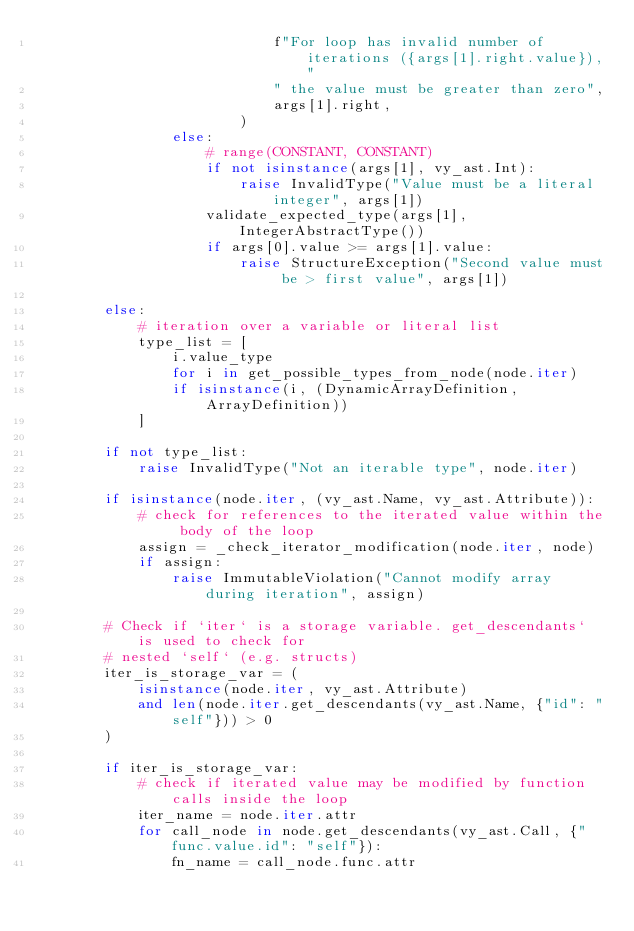<code> <loc_0><loc_0><loc_500><loc_500><_Python_>                            f"For loop has invalid number of iterations ({args[1].right.value}),"
                            " the value must be greater than zero",
                            args[1].right,
                        )
                else:
                    # range(CONSTANT, CONSTANT)
                    if not isinstance(args[1], vy_ast.Int):
                        raise InvalidType("Value must be a literal integer", args[1])
                    validate_expected_type(args[1], IntegerAbstractType())
                    if args[0].value >= args[1].value:
                        raise StructureException("Second value must be > first value", args[1])

        else:
            # iteration over a variable or literal list
            type_list = [
                i.value_type
                for i in get_possible_types_from_node(node.iter)
                if isinstance(i, (DynamicArrayDefinition, ArrayDefinition))
            ]

        if not type_list:
            raise InvalidType("Not an iterable type", node.iter)

        if isinstance(node.iter, (vy_ast.Name, vy_ast.Attribute)):
            # check for references to the iterated value within the body of the loop
            assign = _check_iterator_modification(node.iter, node)
            if assign:
                raise ImmutableViolation("Cannot modify array during iteration", assign)

        # Check if `iter` is a storage variable. get_descendants` is used to check for
        # nested `self` (e.g. structs)
        iter_is_storage_var = (
            isinstance(node.iter, vy_ast.Attribute)
            and len(node.iter.get_descendants(vy_ast.Name, {"id": "self"})) > 0
        )

        if iter_is_storage_var:
            # check if iterated value may be modified by function calls inside the loop
            iter_name = node.iter.attr
            for call_node in node.get_descendants(vy_ast.Call, {"func.value.id": "self"}):
                fn_name = call_node.func.attr
</code> 